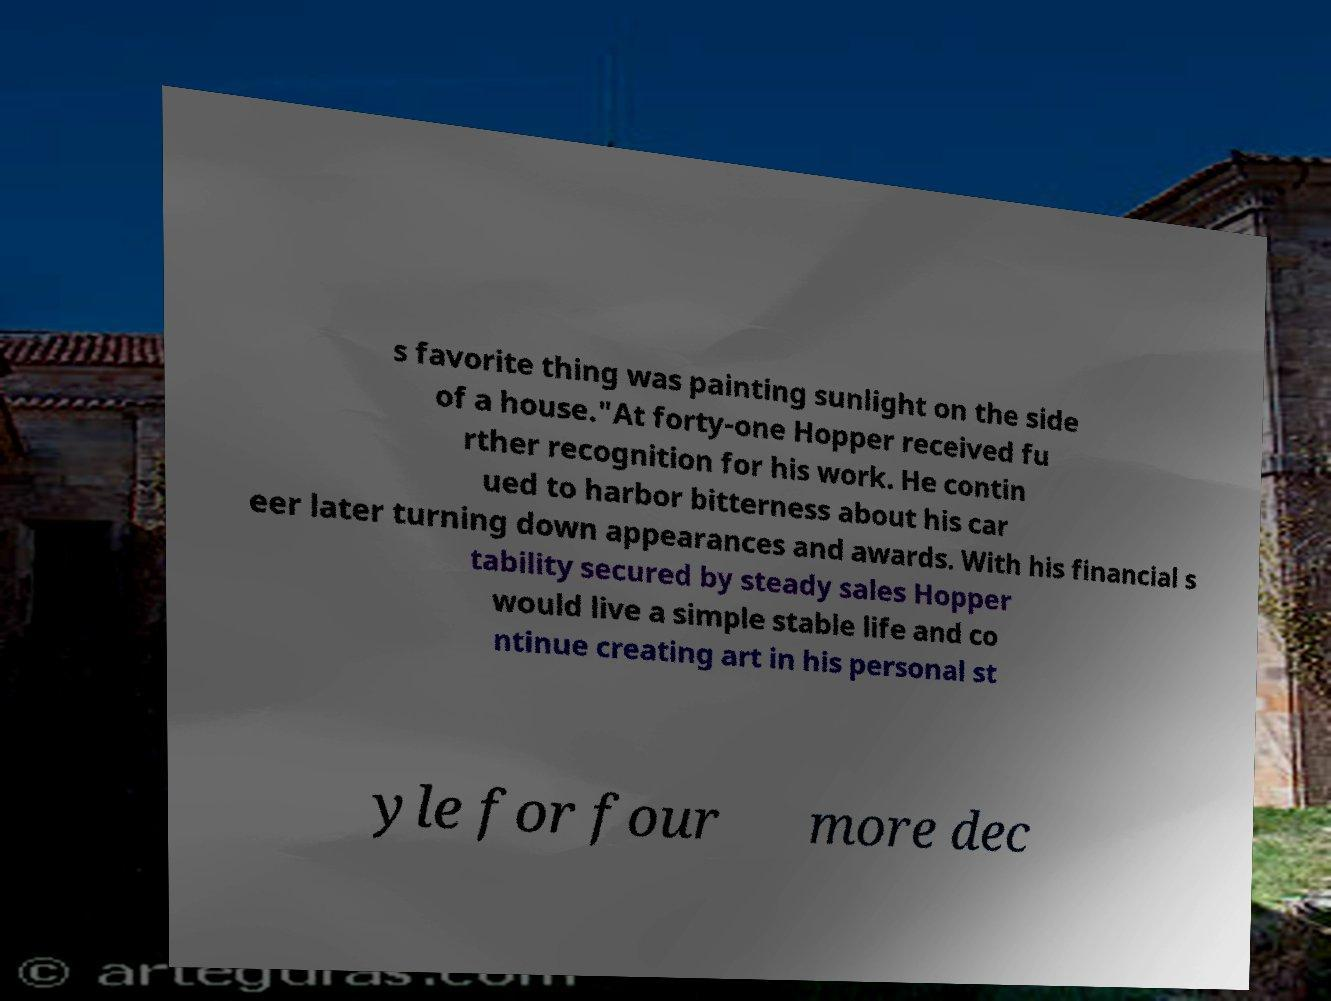I need the written content from this picture converted into text. Can you do that? s favorite thing was painting sunlight on the side of a house."At forty-one Hopper received fu rther recognition for his work. He contin ued to harbor bitterness about his car eer later turning down appearances and awards. With his financial s tability secured by steady sales Hopper would live a simple stable life and co ntinue creating art in his personal st yle for four more dec 